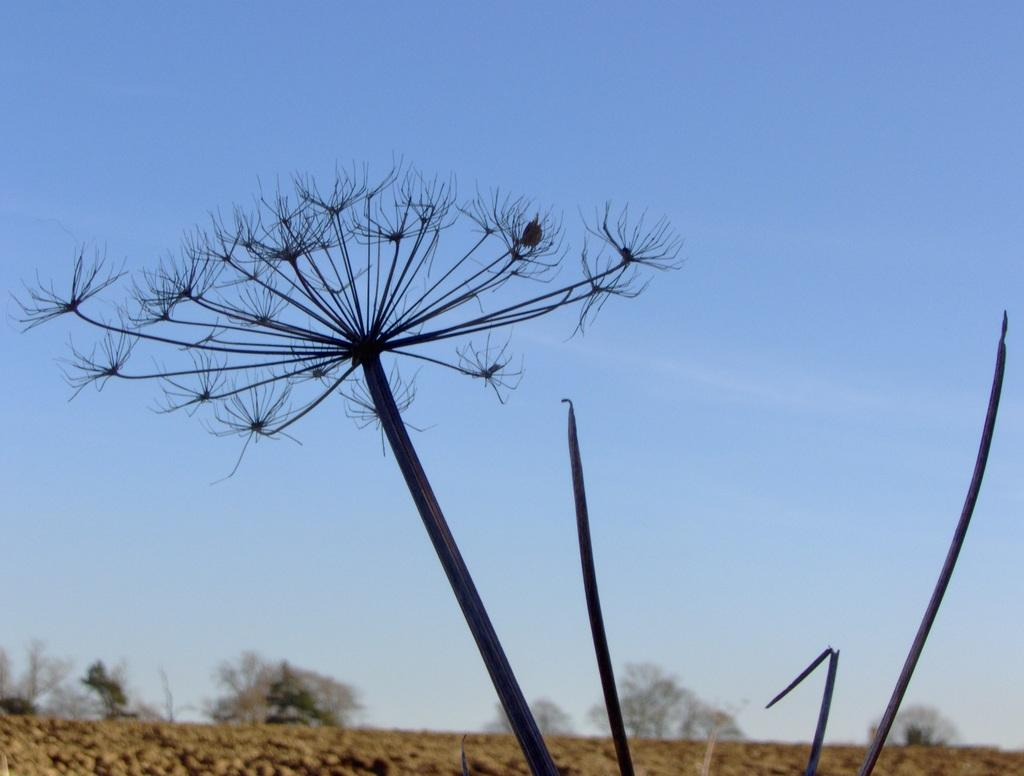What type of living organism can be seen in the image? There is a plant in the image. What is the color of the plant? The plant is black in color. What is visible beneath the plant in the image? The ground is visible in the image. What other types of vegetation can be seen in the image? There are trees in the image. What is visible in the background of the image? The sky is visible in the background of the image. Can you see the girl's toe in the image? There is no girl or toe present in the image; it features a black plant, trees, and the sky. 